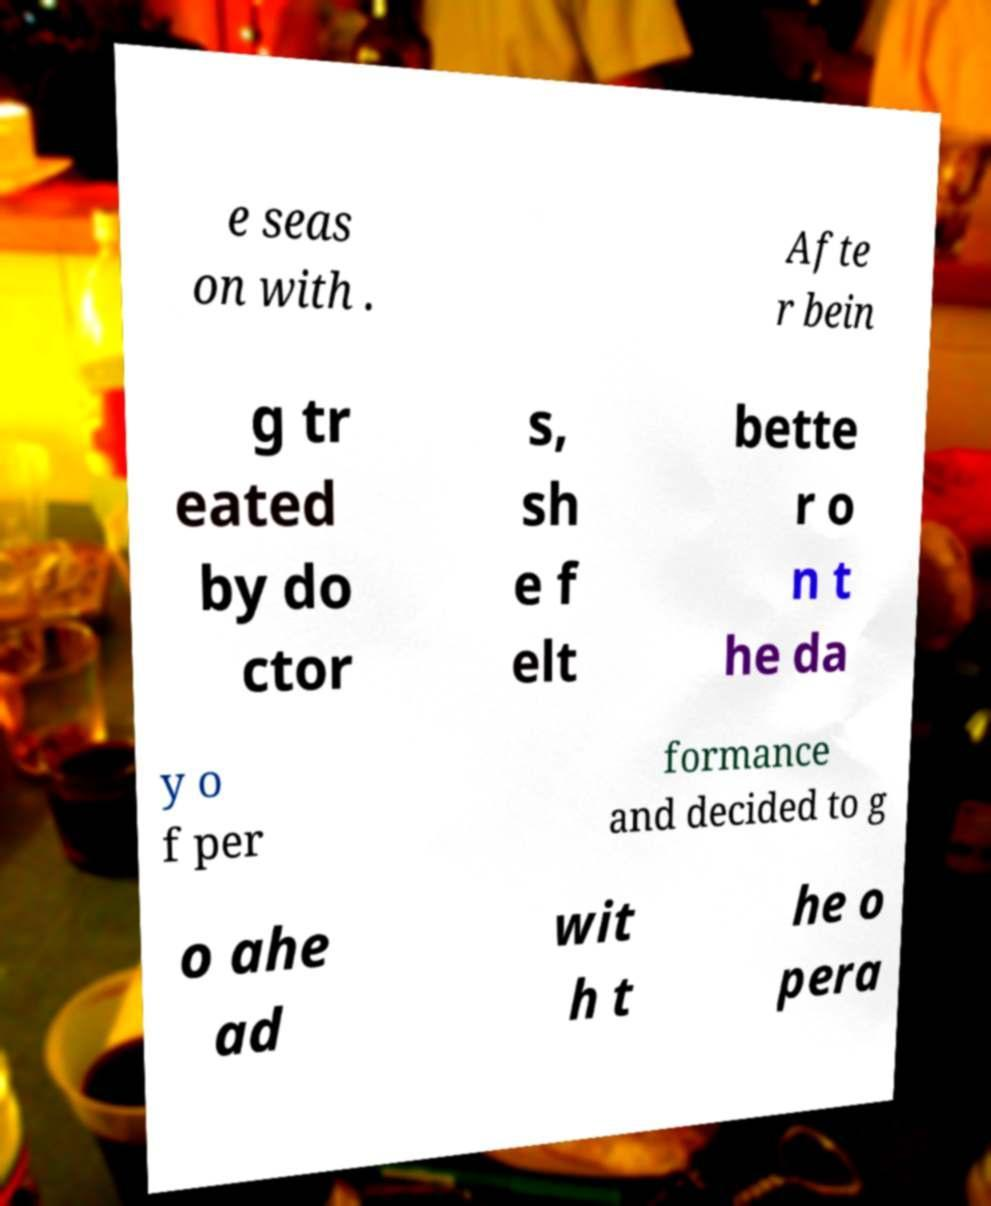Please identify and transcribe the text found in this image. e seas on with . Afte r bein g tr eated by do ctor s, sh e f elt bette r o n t he da y o f per formance and decided to g o ahe ad wit h t he o pera 